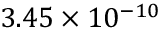<formula> <loc_0><loc_0><loc_500><loc_500>3 . 4 5 \times 1 0 ^ { - 1 0 }</formula> 